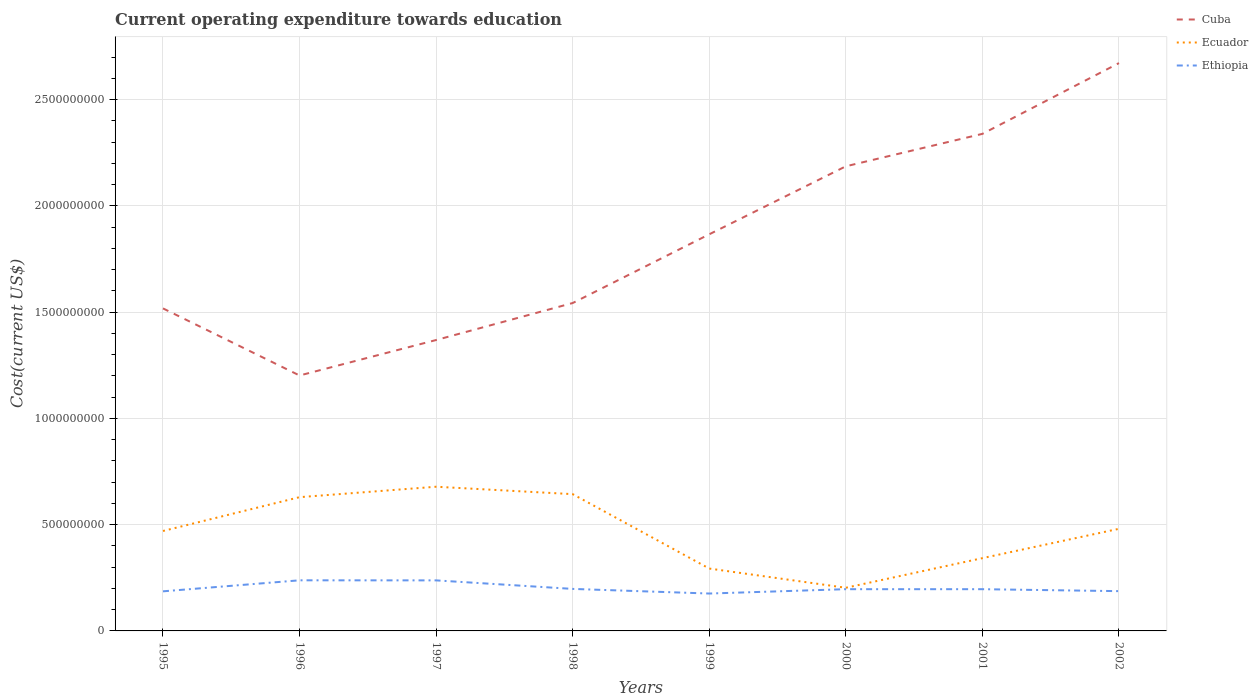Does the line corresponding to Ethiopia intersect with the line corresponding to Cuba?
Offer a terse response. No. Is the number of lines equal to the number of legend labels?
Ensure brevity in your answer.  Yes. Across all years, what is the maximum expenditure towards education in Cuba?
Make the answer very short. 1.20e+09. In which year was the expenditure towards education in Cuba maximum?
Your response must be concise. 1996. What is the total expenditure towards education in Ecuador in the graph?
Provide a succinct answer. 2.87e+08. What is the difference between the highest and the second highest expenditure towards education in Ethiopia?
Your answer should be compact. 6.22e+07. Is the expenditure towards education in Cuba strictly greater than the expenditure towards education in Ethiopia over the years?
Offer a terse response. No. How many years are there in the graph?
Give a very brief answer. 8. What is the difference between two consecutive major ticks on the Y-axis?
Provide a succinct answer. 5.00e+08. Does the graph contain grids?
Your response must be concise. Yes. Where does the legend appear in the graph?
Provide a short and direct response. Top right. How many legend labels are there?
Offer a terse response. 3. What is the title of the graph?
Offer a terse response. Current operating expenditure towards education. Does "Uganda" appear as one of the legend labels in the graph?
Provide a succinct answer. No. What is the label or title of the X-axis?
Ensure brevity in your answer.  Years. What is the label or title of the Y-axis?
Provide a short and direct response. Cost(current US$). What is the Cost(current US$) in Cuba in 1995?
Offer a terse response. 1.52e+09. What is the Cost(current US$) of Ecuador in 1995?
Offer a very short reply. 4.70e+08. What is the Cost(current US$) in Ethiopia in 1995?
Your response must be concise. 1.86e+08. What is the Cost(current US$) in Cuba in 1996?
Provide a short and direct response. 1.20e+09. What is the Cost(current US$) of Ecuador in 1996?
Give a very brief answer. 6.29e+08. What is the Cost(current US$) of Ethiopia in 1996?
Make the answer very short. 2.38e+08. What is the Cost(current US$) in Cuba in 1997?
Your answer should be compact. 1.37e+09. What is the Cost(current US$) of Ecuador in 1997?
Keep it short and to the point. 6.78e+08. What is the Cost(current US$) of Ethiopia in 1997?
Give a very brief answer. 2.38e+08. What is the Cost(current US$) of Cuba in 1998?
Provide a short and direct response. 1.54e+09. What is the Cost(current US$) of Ecuador in 1998?
Provide a short and direct response. 6.43e+08. What is the Cost(current US$) in Ethiopia in 1998?
Provide a succinct answer. 1.98e+08. What is the Cost(current US$) in Cuba in 1999?
Provide a succinct answer. 1.87e+09. What is the Cost(current US$) in Ecuador in 1999?
Your answer should be compact. 2.93e+08. What is the Cost(current US$) of Ethiopia in 1999?
Offer a terse response. 1.76e+08. What is the Cost(current US$) of Cuba in 2000?
Provide a succinct answer. 2.19e+09. What is the Cost(current US$) in Ecuador in 2000?
Your answer should be compact. 2.03e+08. What is the Cost(current US$) in Ethiopia in 2000?
Offer a very short reply. 1.96e+08. What is the Cost(current US$) of Cuba in 2001?
Provide a short and direct response. 2.34e+09. What is the Cost(current US$) of Ecuador in 2001?
Your response must be concise. 3.42e+08. What is the Cost(current US$) of Ethiopia in 2001?
Ensure brevity in your answer.  1.96e+08. What is the Cost(current US$) in Cuba in 2002?
Your answer should be very brief. 2.67e+09. What is the Cost(current US$) in Ecuador in 2002?
Provide a short and direct response. 4.80e+08. What is the Cost(current US$) of Ethiopia in 2002?
Keep it short and to the point. 1.87e+08. Across all years, what is the maximum Cost(current US$) in Cuba?
Offer a terse response. 2.67e+09. Across all years, what is the maximum Cost(current US$) in Ecuador?
Provide a succinct answer. 6.78e+08. Across all years, what is the maximum Cost(current US$) of Ethiopia?
Make the answer very short. 2.38e+08. Across all years, what is the minimum Cost(current US$) of Cuba?
Your answer should be very brief. 1.20e+09. Across all years, what is the minimum Cost(current US$) of Ecuador?
Provide a succinct answer. 2.03e+08. Across all years, what is the minimum Cost(current US$) in Ethiopia?
Your response must be concise. 1.76e+08. What is the total Cost(current US$) of Cuba in the graph?
Make the answer very short. 1.47e+1. What is the total Cost(current US$) in Ecuador in the graph?
Keep it short and to the point. 3.74e+09. What is the total Cost(current US$) in Ethiopia in the graph?
Give a very brief answer. 1.62e+09. What is the difference between the Cost(current US$) of Cuba in 1995 and that in 1996?
Provide a short and direct response. 3.16e+08. What is the difference between the Cost(current US$) of Ecuador in 1995 and that in 1996?
Provide a succinct answer. -1.59e+08. What is the difference between the Cost(current US$) in Ethiopia in 1995 and that in 1996?
Provide a short and direct response. -5.18e+07. What is the difference between the Cost(current US$) in Cuba in 1995 and that in 1997?
Give a very brief answer. 1.49e+08. What is the difference between the Cost(current US$) in Ecuador in 1995 and that in 1997?
Your answer should be very brief. -2.08e+08. What is the difference between the Cost(current US$) in Ethiopia in 1995 and that in 1997?
Offer a terse response. -5.15e+07. What is the difference between the Cost(current US$) in Cuba in 1995 and that in 1998?
Offer a very short reply. -2.52e+07. What is the difference between the Cost(current US$) in Ecuador in 1995 and that in 1998?
Make the answer very short. -1.73e+08. What is the difference between the Cost(current US$) of Ethiopia in 1995 and that in 1998?
Offer a very short reply. -1.14e+07. What is the difference between the Cost(current US$) in Cuba in 1995 and that in 1999?
Your response must be concise. -3.49e+08. What is the difference between the Cost(current US$) in Ecuador in 1995 and that in 1999?
Give a very brief answer. 1.77e+08. What is the difference between the Cost(current US$) of Ethiopia in 1995 and that in 1999?
Provide a succinct answer. 1.04e+07. What is the difference between the Cost(current US$) of Cuba in 1995 and that in 2000?
Your response must be concise. -6.69e+08. What is the difference between the Cost(current US$) in Ecuador in 1995 and that in 2000?
Make the answer very short. 2.67e+08. What is the difference between the Cost(current US$) of Ethiopia in 1995 and that in 2000?
Provide a succinct answer. -1.01e+07. What is the difference between the Cost(current US$) in Cuba in 1995 and that in 2001?
Ensure brevity in your answer.  -8.21e+08. What is the difference between the Cost(current US$) in Ecuador in 1995 and that in 2001?
Ensure brevity in your answer.  1.28e+08. What is the difference between the Cost(current US$) of Ethiopia in 1995 and that in 2001?
Keep it short and to the point. -1.00e+07. What is the difference between the Cost(current US$) of Cuba in 1995 and that in 2002?
Make the answer very short. -1.15e+09. What is the difference between the Cost(current US$) of Ecuador in 1995 and that in 2002?
Offer a terse response. -1.03e+07. What is the difference between the Cost(current US$) of Ethiopia in 1995 and that in 2002?
Ensure brevity in your answer.  -8.46e+05. What is the difference between the Cost(current US$) of Cuba in 1996 and that in 1997?
Provide a succinct answer. -1.67e+08. What is the difference between the Cost(current US$) in Ecuador in 1996 and that in 1997?
Make the answer very short. -4.91e+07. What is the difference between the Cost(current US$) of Ethiopia in 1996 and that in 1997?
Ensure brevity in your answer.  3.39e+05. What is the difference between the Cost(current US$) of Cuba in 1996 and that in 1998?
Give a very brief answer. -3.41e+08. What is the difference between the Cost(current US$) in Ecuador in 1996 and that in 1998?
Make the answer very short. -1.42e+07. What is the difference between the Cost(current US$) of Ethiopia in 1996 and that in 1998?
Ensure brevity in your answer.  4.05e+07. What is the difference between the Cost(current US$) in Cuba in 1996 and that in 1999?
Keep it short and to the point. -6.64e+08. What is the difference between the Cost(current US$) in Ecuador in 1996 and that in 1999?
Offer a very short reply. 3.36e+08. What is the difference between the Cost(current US$) of Ethiopia in 1996 and that in 1999?
Your answer should be very brief. 6.22e+07. What is the difference between the Cost(current US$) of Cuba in 1996 and that in 2000?
Offer a very short reply. -9.84e+08. What is the difference between the Cost(current US$) in Ecuador in 1996 and that in 2000?
Your answer should be very brief. 4.26e+08. What is the difference between the Cost(current US$) of Ethiopia in 1996 and that in 2000?
Your answer should be very brief. 4.17e+07. What is the difference between the Cost(current US$) of Cuba in 1996 and that in 2001?
Offer a very short reply. -1.14e+09. What is the difference between the Cost(current US$) in Ecuador in 1996 and that in 2001?
Give a very brief answer. 2.87e+08. What is the difference between the Cost(current US$) in Ethiopia in 1996 and that in 2001?
Offer a very short reply. 4.18e+07. What is the difference between the Cost(current US$) in Cuba in 1996 and that in 2002?
Give a very brief answer. -1.47e+09. What is the difference between the Cost(current US$) of Ecuador in 1996 and that in 2002?
Provide a succinct answer. 1.49e+08. What is the difference between the Cost(current US$) in Ethiopia in 1996 and that in 2002?
Make the answer very short. 5.10e+07. What is the difference between the Cost(current US$) of Cuba in 1997 and that in 1998?
Your answer should be compact. -1.74e+08. What is the difference between the Cost(current US$) of Ecuador in 1997 and that in 1998?
Provide a short and direct response. 3.49e+07. What is the difference between the Cost(current US$) in Ethiopia in 1997 and that in 1998?
Make the answer very short. 4.01e+07. What is the difference between the Cost(current US$) in Cuba in 1997 and that in 1999?
Your response must be concise. -4.97e+08. What is the difference between the Cost(current US$) of Ecuador in 1997 and that in 1999?
Offer a terse response. 3.85e+08. What is the difference between the Cost(current US$) in Ethiopia in 1997 and that in 1999?
Your answer should be very brief. 6.19e+07. What is the difference between the Cost(current US$) in Cuba in 1997 and that in 2000?
Ensure brevity in your answer.  -8.17e+08. What is the difference between the Cost(current US$) in Ecuador in 1997 and that in 2000?
Give a very brief answer. 4.75e+08. What is the difference between the Cost(current US$) of Ethiopia in 1997 and that in 2000?
Keep it short and to the point. 4.14e+07. What is the difference between the Cost(current US$) of Cuba in 1997 and that in 2001?
Your response must be concise. -9.70e+08. What is the difference between the Cost(current US$) in Ecuador in 1997 and that in 2001?
Provide a short and direct response. 3.36e+08. What is the difference between the Cost(current US$) of Ethiopia in 1997 and that in 2001?
Your answer should be very brief. 4.15e+07. What is the difference between the Cost(current US$) in Cuba in 1997 and that in 2002?
Offer a terse response. -1.30e+09. What is the difference between the Cost(current US$) of Ecuador in 1997 and that in 2002?
Make the answer very short. 1.98e+08. What is the difference between the Cost(current US$) in Ethiopia in 1997 and that in 2002?
Provide a short and direct response. 5.07e+07. What is the difference between the Cost(current US$) of Cuba in 1998 and that in 1999?
Ensure brevity in your answer.  -3.23e+08. What is the difference between the Cost(current US$) in Ecuador in 1998 and that in 1999?
Ensure brevity in your answer.  3.50e+08. What is the difference between the Cost(current US$) of Ethiopia in 1998 and that in 1999?
Give a very brief answer. 2.18e+07. What is the difference between the Cost(current US$) in Cuba in 1998 and that in 2000?
Give a very brief answer. -6.43e+08. What is the difference between the Cost(current US$) in Ecuador in 1998 and that in 2000?
Offer a terse response. 4.40e+08. What is the difference between the Cost(current US$) in Ethiopia in 1998 and that in 2000?
Make the answer very short. 1.30e+06. What is the difference between the Cost(current US$) of Cuba in 1998 and that in 2001?
Your answer should be very brief. -7.96e+08. What is the difference between the Cost(current US$) in Ecuador in 1998 and that in 2001?
Keep it short and to the point. 3.01e+08. What is the difference between the Cost(current US$) in Ethiopia in 1998 and that in 2001?
Offer a terse response. 1.35e+06. What is the difference between the Cost(current US$) in Cuba in 1998 and that in 2002?
Give a very brief answer. -1.13e+09. What is the difference between the Cost(current US$) of Ecuador in 1998 and that in 2002?
Provide a succinct answer. 1.63e+08. What is the difference between the Cost(current US$) of Ethiopia in 1998 and that in 2002?
Offer a terse response. 1.05e+07. What is the difference between the Cost(current US$) of Cuba in 1999 and that in 2000?
Your response must be concise. -3.20e+08. What is the difference between the Cost(current US$) in Ecuador in 1999 and that in 2000?
Your answer should be compact. 9.04e+07. What is the difference between the Cost(current US$) in Ethiopia in 1999 and that in 2000?
Offer a very short reply. -2.05e+07. What is the difference between the Cost(current US$) in Cuba in 1999 and that in 2001?
Your answer should be compact. -4.73e+08. What is the difference between the Cost(current US$) in Ecuador in 1999 and that in 2001?
Your response must be concise. -4.90e+07. What is the difference between the Cost(current US$) of Ethiopia in 1999 and that in 2001?
Offer a terse response. -2.04e+07. What is the difference between the Cost(current US$) in Cuba in 1999 and that in 2002?
Ensure brevity in your answer.  -8.05e+08. What is the difference between the Cost(current US$) in Ecuador in 1999 and that in 2002?
Your answer should be compact. -1.87e+08. What is the difference between the Cost(current US$) in Ethiopia in 1999 and that in 2002?
Provide a succinct answer. -1.12e+07. What is the difference between the Cost(current US$) in Cuba in 2000 and that in 2001?
Offer a very short reply. -1.53e+08. What is the difference between the Cost(current US$) of Ecuador in 2000 and that in 2001?
Give a very brief answer. -1.39e+08. What is the difference between the Cost(current US$) of Ethiopia in 2000 and that in 2001?
Offer a very short reply. 5.27e+04. What is the difference between the Cost(current US$) of Cuba in 2000 and that in 2002?
Make the answer very short. -4.86e+08. What is the difference between the Cost(current US$) of Ecuador in 2000 and that in 2002?
Your answer should be compact. -2.77e+08. What is the difference between the Cost(current US$) in Ethiopia in 2000 and that in 2002?
Offer a terse response. 9.24e+06. What is the difference between the Cost(current US$) in Cuba in 2001 and that in 2002?
Your answer should be very brief. -3.33e+08. What is the difference between the Cost(current US$) in Ecuador in 2001 and that in 2002?
Ensure brevity in your answer.  -1.38e+08. What is the difference between the Cost(current US$) of Ethiopia in 2001 and that in 2002?
Ensure brevity in your answer.  9.19e+06. What is the difference between the Cost(current US$) of Cuba in 1995 and the Cost(current US$) of Ecuador in 1996?
Your answer should be very brief. 8.88e+08. What is the difference between the Cost(current US$) of Cuba in 1995 and the Cost(current US$) of Ethiopia in 1996?
Keep it short and to the point. 1.28e+09. What is the difference between the Cost(current US$) in Ecuador in 1995 and the Cost(current US$) in Ethiopia in 1996?
Provide a short and direct response. 2.32e+08. What is the difference between the Cost(current US$) of Cuba in 1995 and the Cost(current US$) of Ecuador in 1997?
Your answer should be compact. 8.39e+08. What is the difference between the Cost(current US$) of Cuba in 1995 and the Cost(current US$) of Ethiopia in 1997?
Ensure brevity in your answer.  1.28e+09. What is the difference between the Cost(current US$) of Ecuador in 1995 and the Cost(current US$) of Ethiopia in 1997?
Provide a succinct answer. 2.32e+08. What is the difference between the Cost(current US$) in Cuba in 1995 and the Cost(current US$) in Ecuador in 1998?
Ensure brevity in your answer.  8.74e+08. What is the difference between the Cost(current US$) in Cuba in 1995 and the Cost(current US$) in Ethiopia in 1998?
Provide a short and direct response. 1.32e+09. What is the difference between the Cost(current US$) of Ecuador in 1995 and the Cost(current US$) of Ethiopia in 1998?
Provide a succinct answer. 2.72e+08. What is the difference between the Cost(current US$) in Cuba in 1995 and the Cost(current US$) in Ecuador in 1999?
Keep it short and to the point. 1.22e+09. What is the difference between the Cost(current US$) in Cuba in 1995 and the Cost(current US$) in Ethiopia in 1999?
Keep it short and to the point. 1.34e+09. What is the difference between the Cost(current US$) in Ecuador in 1995 and the Cost(current US$) in Ethiopia in 1999?
Ensure brevity in your answer.  2.94e+08. What is the difference between the Cost(current US$) of Cuba in 1995 and the Cost(current US$) of Ecuador in 2000?
Give a very brief answer. 1.31e+09. What is the difference between the Cost(current US$) in Cuba in 1995 and the Cost(current US$) in Ethiopia in 2000?
Offer a terse response. 1.32e+09. What is the difference between the Cost(current US$) in Ecuador in 1995 and the Cost(current US$) in Ethiopia in 2000?
Give a very brief answer. 2.74e+08. What is the difference between the Cost(current US$) in Cuba in 1995 and the Cost(current US$) in Ecuador in 2001?
Provide a succinct answer. 1.17e+09. What is the difference between the Cost(current US$) in Cuba in 1995 and the Cost(current US$) in Ethiopia in 2001?
Make the answer very short. 1.32e+09. What is the difference between the Cost(current US$) in Ecuador in 1995 and the Cost(current US$) in Ethiopia in 2001?
Your response must be concise. 2.74e+08. What is the difference between the Cost(current US$) in Cuba in 1995 and the Cost(current US$) in Ecuador in 2002?
Provide a short and direct response. 1.04e+09. What is the difference between the Cost(current US$) in Cuba in 1995 and the Cost(current US$) in Ethiopia in 2002?
Your answer should be compact. 1.33e+09. What is the difference between the Cost(current US$) in Ecuador in 1995 and the Cost(current US$) in Ethiopia in 2002?
Provide a short and direct response. 2.83e+08. What is the difference between the Cost(current US$) in Cuba in 1996 and the Cost(current US$) in Ecuador in 1997?
Provide a succinct answer. 5.23e+08. What is the difference between the Cost(current US$) in Cuba in 1996 and the Cost(current US$) in Ethiopia in 1997?
Your answer should be compact. 9.64e+08. What is the difference between the Cost(current US$) of Ecuador in 1996 and the Cost(current US$) of Ethiopia in 1997?
Provide a succinct answer. 3.91e+08. What is the difference between the Cost(current US$) of Cuba in 1996 and the Cost(current US$) of Ecuador in 1998?
Provide a succinct answer. 5.58e+08. What is the difference between the Cost(current US$) of Cuba in 1996 and the Cost(current US$) of Ethiopia in 1998?
Your answer should be compact. 1.00e+09. What is the difference between the Cost(current US$) in Ecuador in 1996 and the Cost(current US$) in Ethiopia in 1998?
Your answer should be very brief. 4.32e+08. What is the difference between the Cost(current US$) of Cuba in 1996 and the Cost(current US$) of Ecuador in 1999?
Offer a terse response. 9.08e+08. What is the difference between the Cost(current US$) in Cuba in 1996 and the Cost(current US$) in Ethiopia in 1999?
Ensure brevity in your answer.  1.03e+09. What is the difference between the Cost(current US$) in Ecuador in 1996 and the Cost(current US$) in Ethiopia in 1999?
Your response must be concise. 4.53e+08. What is the difference between the Cost(current US$) in Cuba in 1996 and the Cost(current US$) in Ecuador in 2000?
Provide a short and direct response. 9.99e+08. What is the difference between the Cost(current US$) in Cuba in 1996 and the Cost(current US$) in Ethiopia in 2000?
Make the answer very short. 1.01e+09. What is the difference between the Cost(current US$) in Ecuador in 1996 and the Cost(current US$) in Ethiopia in 2000?
Provide a short and direct response. 4.33e+08. What is the difference between the Cost(current US$) of Cuba in 1996 and the Cost(current US$) of Ecuador in 2001?
Your response must be concise. 8.59e+08. What is the difference between the Cost(current US$) in Cuba in 1996 and the Cost(current US$) in Ethiopia in 2001?
Your response must be concise. 1.01e+09. What is the difference between the Cost(current US$) of Ecuador in 1996 and the Cost(current US$) of Ethiopia in 2001?
Give a very brief answer. 4.33e+08. What is the difference between the Cost(current US$) in Cuba in 1996 and the Cost(current US$) in Ecuador in 2002?
Keep it short and to the point. 7.21e+08. What is the difference between the Cost(current US$) in Cuba in 1996 and the Cost(current US$) in Ethiopia in 2002?
Provide a succinct answer. 1.01e+09. What is the difference between the Cost(current US$) in Ecuador in 1996 and the Cost(current US$) in Ethiopia in 2002?
Your response must be concise. 4.42e+08. What is the difference between the Cost(current US$) of Cuba in 1997 and the Cost(current US$) of Ecuador in 1998?
Give a very brief answer. 7.25e+08. What is the difference between the Cost(current US$) in Cuba in 1997 and the Cost(current US$) in Ethiopia in 1998?
Provide a short and direct response. 1.17e+09. What is the difference between the Cost(current US$) in Ecuador in 1997 and the Cost(current US$) in Ethiopia in 1998?
Your response must be concise. 4.81e+08. What is the difference between the Cost(current US$) in Cuba in 1997 and the Cost(current US$) in Ecuador in 1999?
Your answer should be compact. 1.08e+09. What is the difference between the Cost(current US$) of Cuba in 1997 and the Cost(current US$) of Ethiopia in 1999?
Give a very brief answer. 1.19e+09. What is the difference between the Cost(current US$) in Ecuador in 1997 and the Cost(current US$) in Ethiopia in 1999?
Provide a short and direct response. 5.02e+08. What is the difference between the Cost(current US$) in Cuba in 1997 and the Cost(current US$) in Ecuador in 2000?
Offer a very short reply. 1.17e+09. What is the difference between the Cost(current US$) in Cuba in 1997 and the Cost(current US$) in Ethiopia in 2000?
Make the answer very short. 1.17e+09. What is the difference between the Cost(current US$) of Ecuador in 1997 and the Cost(current US$) of Ethiopia in 2000?
Provide a short and direct response. 4.82e+08. What is the difference between the Cost(current US$) in Cuba in 1997 and the Cost(current US$) in Ecuador in 2001?
Your response must be concise. 1.03e+09. What is the difference between the Cost(current US$) of Cuba in 1997 and the Cost(current US$) of Ethiopia in 2001?
Provide a short and direct response. 1.17e+09. What is the difference between the Cost(current US$) of Ecuador in 1997 and the Cost(current US$) of Ethiopia in 2001?
Ensure brevity in your answer.  4.82e+08. What is the difference between the Cost(current US$) of Cuba in 1997 and the Cost(current US$) of Ecuador in 2002?
Offer a very short reply. 8.88e+08. What is the difference between the Cost(current US$) of Cuba in 1997 and the Cost(current US$) of Ethiopia in 2002?
Your response must be concise. 1.18e+09. What is the difference between the Cost(current US$) of Ecuador in 1997 and the Cost(current US$) of Ethiopia in 2002?
Offer a very short reply. 4.91e+08. What is the difference between the Cost(current US$) of Cuba in 1998 and the Cost(current US$) of Ecuador in 1999?
Keep it short and to the point. 1.25e+09. What is the difference between the Cost(current US$) of Cuba in 1998 and the Cost(current US$) of Ethiopia in 1999?
Your answer should be compact. 1.37e+09. What is the difference between the Cost(current US$) of Ecuador in 1998 and the Cost(current US$) of Ethiopia in 1999?
Provide a succinct answer. 4.68e+08. What is the difference between the Cost(current US$) in Cuba in 1998 and the Cost(current US$) in Ecuador in 2000?
Provide a short and direct response. 1.34e+09. What is the difference between the Cost(current US$) in Cuba in 1998 and the Cost(current US$) in Ethiopia in 2000?
Your answer should be compact. 1.35e+09. What is the difference between the Cost(current US$) of Ecuador in 1998 and the Cost(current US$) of Ethiopia in 2000?
Make the answer very short. 4.47e+08. What is the difference between the Cost(current US$) of Cuba in 1998 and the Cost(current US$) of Ecuador in 2001?
Your answer should be very brief. 1.20e+09. What is the difference between the Cost(current US$) in Cuba in 1998 and the Cost(current US$) in Ethiopia in 2001?
Your response must be concise. 1.35e+09. What is the difference between the Cost(current US$) in Ecuador in 1998 and the Cost(current US$) in Ethiopia in 2001?
Your response must be concise. 4.47e+08. What is the difference between the Cost(current US$) of Cuba in 1998 and the Cost(current US$) of Ecuador in 2002?
Keep it short and to the point. 1.06e+09. What is the difference between the Cost(current US$) of Cuba in 1998 and the Cost(current US$) of Ethiopia in 2002?
Your answer should be very brief. 1.36e+09. What is the difference between the Cost(current US$) of Ecuador in 1998 and the Cost(current US$) of Ethiopia in 2002?
Keep it short and to the point. 4.56e+08. What is the difference between the Cost(current US$) of Cuba in 1999 and the Cost(current US$) of Ecuador in 2000?
Offer a terse response. 1.66e+09. What is the difference between the Cost(current US$) in Cuba in 1999 and the Cost(current US$) in Ethiopia in 2000?
Ensure brevity in your answer.  1.67e+09. What is the difference between the Cost(current US$) in Ecuador in 1999 and the Cost(current US$) in Ethiopia in 2000?
Make the answer very short. 9.70e+07. What is the difference between the Cost(current US$) of Cuba in 1999 and the Cost(current US$) of Ecuador in 2001?
Your answer should be very brief. 1.52e+09. What is the difference between the Cost(current US$) in Cuba in 1999 and the Cost(current US$) in Ethiopia in 2001?
Offer a very short reply. 1.67e+09. What is the difference between the Cost(current US$) in Ecuador in 1999 and the Cost(current US$) in Ethiopia in 2001?
Provide a succinct answer. 9.71e+07. What is the difference between the Cost(current US$) of Cuba in 1999 and the Cost(current US$) of Ecuador in 2002?
Keep it short and to the point. 1.39e+09. What is the difference between the Cost(current US$) in Cuba in 1999 and the Cost(current US$) in Ethiopia in 2002?
Provide a succinct answer. 1.68e+09. What is the difference between the Cost(current US$) in Ecuador in 1999 and the Cost(current US$) in Ethiopia in 2002?
Offer a very short reply. 1.06e+08. What is the difference between the Cost(current US$) of Cuba in 2000 and the Cost(current US$) of Ecuador in 2001?
Offer a terse response. 1.84e+09. What is the difference between the Cost(current US$) in Cuba in 2000 and the Cost(current US$) in Ethiopia in 2001?
Provide a succinct answer. 1.99e+09. What is the difference between the Cost(current US$) of Ecuador in 2000 and the Cost(current US$) of Ethiopia in 2001?
Your answer should be very brief. 6.67e+06. What is the difference between the Cost(current US$) of Cuba in 2000 and the Cost(current US$) of Ecuador in 2002?
Make the answer very short. 1.71e+09. What is the difference between the Cost(current US$) of Cuba in 2000 and the Cost(current US$) of Ethiopia in 2002?
Offer a very short reply. 2.00e+09. What is the difference between the Cost(current US$) in Ecuador in 2000 and the Cost(current US$) in Ethiopia in 2002?
Keep it short and to the point. 1.59e+07. What is the difference between the Cost(current US$) in Cuba in 2001 and the Cost(current US$) in Ecuador in 2002?
Your answer should be compact. 1.86e+09. What is the difference between the Cost(current US$) of Cuba in 2001 and the Cost(current US$) of Ethiopia in 2002?
Your answer should be very brief. 2.15e+09. What is the difference between the Cost(current US$) of Ecuador in 2001 and the Cost(current US$) of Ethiopia in 2002?
Ensure brevity in your answer.  1.55e+08. What is the average Cost(current US$) of Cuba per year?
Your answer should be very brief. 1.84e+09. What is the average Cost(current US$) in Ecuador per year?
Provide a succinct answer. 4.68e+08. What is the average Cost(current US$) in Ethiopia per year?
Keep it short and to the point. 2.02e+08. In the year 1995, what is the difference between the Cost(current US$) in Cuba and Cost(current US$) in Ecuador?
Give a very brief answer. 1.05e+09. In the year 1995, what is the difference between the Cost(current US$) of Cuba and Cost(current US$) of Ethiopia?
Keep it short and to the point. 1.33e+09. In the year 1995, what is the difference between the Cost(current US$) in Ecuador and Cost(current US$) in Ethiopia?
Your answer should be very brief. 2.84e+08. In the year 1996, what is the difference between the Cost(current US$) of Cuba and Cost(current US$) of Ecuador?
Make the answer very short. 5.72e+08. In the year 1996, what is the difference between the Cost(current US$) in Cuba and Cost(current US$) in Ethiopia?
Make the answer very short. 9.64e+08. In the year 1996, what is the difference between the Cost(current US$) in Ecuador and Cost(current US$) in Ethiopia?
Offer a terse response. 3.91e+08. In the year 1997, what is the difference between the Cost(current US$) in Cuba and Cost(current US$) in Ecuador?
Your answer should be compact. 6.90e+08. In the year 1997, what is the difference between the Cost(current US$) of Cuba and Cost(current US$) of Ethiopia?
Provide a short and direct response. 1.13e+09. In the year 1997, what is the difference between the Cost(current US$) of Ecuador and Cost(current US$) of Ethiopia?
Your answer should be compact. 4.41e+08. In the year 1998, what is the difference between the Cost(current US$) of Cuba and Cost(current US$) of Ecuador?
Your response must be concise. 8.99e+08. In the year 1998, what is the difference between the Cost(current US$) of Cuba and Cost(current US$) of Ethiopia?
Your response must be concise. 1.34e+09. In the year 1998, what is the difference between the Cost(current US$) of Ecuador and Cost(current US$) of Ethiopia?
Ensure brevity in your answer.  4.46e+08. In the year 1999, what is the difference between the Cost(current US$) in Cuba and Cost(current US$) in Ecuador?
Give a very brief answer. 1.57e+09. In the year 1999, what is the difference between the Cost(current US$) in Cuba and Cost(current US$) in Ethiopia?
Provide a short and direct response. 1.69e+09. In the year 1999, what is the difference between the Cost(current US$) of Ecuador and Cost(current US$) of Ethiopia?
Offer a very short reply. 1.17e+08. In the year 2000, what is the difference between the Cost(current US$) in Cuba and Cost(current US$) in Ecuador?
Keep it short and to the point. 1.98e+09. In the year 2000, what is the difference between the Cost(current US$) of Cuba and Cost(current US$) of Ethiopia?
Ensure brevity in your answer.  1.99e+09. In the year 2000, what is the difference between the Cost(current US$) in Ecuador and Cost(current US$) in Ethiopia?
Your response must be concise. 6.62e+06. In the year 2001, what is the difference between the Cost(current US$) in Cuba and Cost(current US$) in Ecuador?
Ensure brevity in your answer.  2.00e+09. In the year 2001, what is the difference between the Cost(current US$) in Cuba and Cost(current US$) in Ethiopia?
Keep it short and to the point. 2.14e+09. In the year 2001, what is the difference between the Cost(current US$) in Ecuador and Cost(current US$) in Ethiopia?
Give a very brief answer. 1.46e+08. In the year 2002, what is the difference between the Cost(current US$) in Cuba and Cost(current US$) in Ecuador?
Give a very brief answer. 2.19e+09. In the year 2002, what is the difference between the Cost(current US$) in Cuba and Cost(current US$) in Ethiopia?
Make the answer very short. 2.48e+09. In the year 2002, what is the difference between the Cost(current US$) of Ecuador and Cost(current US$) of Ethiopia?
Provide a succinct answer. 2.93e+08. What is the ratio of the Cost(current US$) of Cuba in 1995 to that in 1996?
Your answer should be very brief. 1.26. What is the ratio of the Cost(current US$) in Ecuador in 1995 to that in 1996?
Provide a short and direct response. 0.75. What is the ratio of the Cost(current US$) of Ethiopia in 1995 to that in 1996?
Your answer should be compact. 0.78. What is the ratio of the Cost(current US$) in Cuba in 1995 to that in 1997?
Your response must be concise. 1.11. What is the ratio of the Cost(current US$) in Ecuador in 1995 to that in 1997?
Ensure brevity in your answer.  0.69. What is the ratio of the Cost(current US$) of Ethiopia in 1995 to that in 1997?
Ensure brevity in your answer.  0.78. What is the ratio of the Cost(current US$) in Cuba in 1995 to that in 1998?
Your response must be concise. 0.98. What is the ratio of the Cost(current US$) of Ecuador in 1995 to that in 1998?
Provide a succinct answer. 0.73. What is the ratio of the Cost(current US$) in Ethiopia in 1995 to that in 1998?
Offer a terse response. 0.94. What is the ratio of the Cost(current US$) in Cuba in 1995 to that in 1999?
Provide a succinct answer. 0.81. What is the ratio of the Cost(current US$) in Ecuador in 1995 to that in 1999?
Provide a short and direct response. 1.6. What is the ratio of the Cost(current US$) of Ethiopia in 1995 to that in 1999?
Your answer should be very brief. 1.06. What is the ratio of the Cost(current US$) in Cuba in 1995 to that in 2000?
Keep it short and to the point. 0.69. What is the ratio of the Cost(current US$) of Ecuador in 1995 to that in 2000?
Offer a terse response. 2.32. What is the ratio of the Cost(current US$) in Ethiopia in 1995 to that in 2000?
Ensure brevity in your answer.  0.95. What is the ratio of the Cost(current US$) of Cuba in 1995 to that in 2001?
Offer a terse response. 0.65. What is the ratio of the Cost(current US$) in Ecuador in 1995 to that in 2001?
Keep it short and to the point. 1.37. What is the ratio of the Cost(current US$) in Ethiopia in 1995 to that in 2001?
Provide a short and direct response. 0.95. What is the ratio of the Cost(current US$) of Cuba in 1995 to that in 2002?
Keep it short and to the point. 0.57. What is the ratio of the Cost(current US$) in Ecuador in 1995 to that in 2002?
Your response must be concise. 0.98. What is the ratio of the Cost(current US$) of Ethiopia in 1995 to that in 2002?
Keep it short and to the point. 1. What is the ratio of the Cost(current US$) in Cuba in 1996 to that in 1997?
Provide a succinct answer. 0.88. What is the ratio of the Cost(current US$) in Ecuador in 1996 to that in 1997?
Give a very brief answer. 0.93. What is the ratio of the Cost(current US$) of Ethiopia in 1996 to that in 1997?
Offer a terse response. 1. What is the ratio of the Cost(current US$) of Cuba in 1996 to that in 1998?
Offer a terse response. 0.78. What is the ratio of the Cost(current US$) of Ethiopia in 1996 to that in 1998?
Your answer should be very brief. 1.2. What is the ratio of the Cost(current US$) in Cuba in 1996 to that in 1999?
Provide a succinct answer. 0.64. What is the ratio of the Cost(current US$) in Ecuador in 1996 to that in 1999?
Give a very brief answer. 2.14. What is the ratio of the Cost(current US$) of Ethiopia in 1996 to that in 1999?
Ensure brevity in your answer.  1.35. What is the ratio of the Cost(current US$) of Cuba in 1996 to that in 2000?
Your answer should be compact. 0.55. What is the ratio of the Cost(current US$) in Ecuador in 1996 to that in 2000?
Your answer should be compact. 3.1. What is the ratio of the Cost(current US$) of Ethiopia in 1996 to that in 2000?
Ensure brevity in your answer.  1.21. What is the ratio of the Cost(current US$) in Cuba in 1996 to that in 2001?
Keep it short and to the point. 0.51. What is the ratio of the Cost(current US$) in Ecuador in 1996 to that in 2001?
Provide a succinct answer. 1.84. What is the ratio of the Cost(current US$) in Ethiopia in 1996 to that in 2001?
Your answer should be compact. 1.21. What is the ratio of the Cost(current US$) in Cuba in 1996 to that in 2002?
Keep it short and to the point. 0.45. What is the ratio of the Cost(current US$) in Ecuador in 1996 to that in 2002?
Provide a succinct answer. 1.31. What is the ratio of the Cost(current US$) of Ethiopia in 1996 to that in 2002?
Your answer should be very brief. 1.27. What is the ratio of the Cost(current US$) in Cuba in 1997 to that in 1998?
Offer a very short reply. 0.89. What is the ratio of the Cost(current US$) of Ecuador in 1997 to that in 1998?
Keep it short and to the point. 1.05. What is the ratio of the Cost(current US$) of Ethiopia in 1997 to that in 1998?
Make the answer very short. 1.2. What is the ratio of the Cost(current US$) of Cuba in 1997 to that in 1999?
Keep it short and to the point. 0.73. What is the ratio of the Cost(current US$) in Ecuador in 1997 to that in 1999?
Your response must be concise. 2.31. What is the ratio of the Cost(current US$) in Ethiopia in 1997 to that in 1999?
Ensure brevity in your answer.  1.35. What is the ratio of the Cost(current US$) of Cuba in 1997 to that in 2000?
Keep it short and to the point. 0.63. What is the ratio of the Cost(current US$) of Ecuador in 1997 to that in 2000?
Keep it short and to the point. 3.34. What is the ratio of the Cost(current US$) in Ethiopia in 1997 to that in 2000?
Your answer should be very brief. 1.21. What is the ratio of the Cost(current US$) in Cuba in 1997 to that in 2001?
Offer a very short reply. 0.59. What is the ratio of the Cost(current US$) of Ecuador in 1997 to that in 2001?
Ensure brevity in your answer.  1.98. What is the ratio of the Cost(current US$) in Ethiopia in 1997 to that in 2001?
Your answer should be very brief. 1.21. What is the ratio of the Cost(current US$) of Cuba in 1997 to that in 2002?
Make the answer very short. 0.51. What is the ratio of the Cost(current US$) of Ecuador in 1997 to that in 2002?
Provide a succinct answer. 1.41. What is the ratio of the Cost(current US$) of Ethiopia in 1997 to that in 2002?
Your answer should be compact. 1.27. What is the ratio of the Cost(current US$) of Cuba in 1998 to that in 1999?
Offer a terse response. 0.83. What is the ratio of the Cost(current US$) in Ecuador in 1998 to that in 1999?
Keep it short and to the point. 2.19. What is the ratio of the Cost(current US$) in Ethiopia in 1998 to that in 1999?
Make the answer very short. 1.12. What is the ratio of the Cost(current US$) in Cuba in 1998 to that in 2000?
Your answer should be very brief. 0.71. What is the ratio of the Cost(current US$) of Ecuador in 1998 to that in 2000?
Offer a very short reply. 3.17. What is the ratio of the Cost(current US$) in Ethiopia in 1998 to that in 2000?
Offer a very short reply. 1.01. What is the ratio of the Cost(current US$) of Cuba in 1998 to that in 2001?
Offer a very short reply. 0.66. What is the ratio of the Cost(current US$) of Ecuador in 1998 to that in 2001?
Make the answer very short. 1.88. What is the ratio of the Cost(current US$) of Cuba in 1998 to that in 2002?
Ensure brevity in your answer.  0.58. What is the ratio of the Cost(current US$) in Ecuador in 1998 to that in 2002?
Ensure brevity in your answer.  1.34. What is the ratio of the Cost(current US$) of Ethiopia in 1998 to that in 2002?
Your answer should be compact. 1.06. What is the ratio of the Cost(current US$) of Cuba in 1999 to that in 2000?
Offer a terse response. 0.85. What is the ratio of the Cost(current US$) in Ecuador in 1999 to that in 2000?
Your answer should be very brief. 1.45. What is the ratio of the Cost(current US$) of Ethiopia in 1999 to that in 2000?
Provide a succinct answer. 0.9. What is the ratio of the Cost(current US$) in Cuba in 1999 to that in 2001?
Give a very brief answer. 0.8. What is the ratio of the Cost(current US$) of Ecuador in 1999 to that in 2001?
Make the answer very short. 0.86. What is the ratio of the Cost(current US$) in Ethiopia in 1999 to that in 2001?
Ensure brevity in your answer.  0.9. What is the ratio of the Cost(current US$) in Cuba in 1999 to that in 2002?
Offer a very short reply. 0.7. What is the ratio of the Cost(current US$) in Ecuador in 1999 to that in 2002?
Give a very brief answer. 0.61. What is the ratio of the Cost(current US$) of Cuba in 2000 to that in 2001?
Keep it short and to the point. 0.93. What is the ratio of the Cost(current US$) in Ecuador in 2000 to that in 2001?
Offer a terse response. 0.59. What is the ratio of the Cost(current US$) of Ethiopia in 2000 to that in 2001?
Provide a succinct answer. 1. What is the ratio of the Cost(current US$) of Cuba in 2000 to that in 2002?
Ensure brevity in your answer.  0.82. What is the ratio of the Cost(current US$) in Ecuador in 2000 to that in 2002?
Your answer should be compact. 0.42. What is the ratio of the Cost(current US$) in Ethiopia in 2000 to that in 2002?
Ensure brevity in your answer.  1.05. What is the ratio of the Cost(current US$) in Cuba in 2001 to that in 2002?
Make the answer very short. 0.88. What is the ratio of the Cost(current US$) in Ecuador in 2001 to that in 2002?
Your answer should be very brief. 0.71. What is the ratio of the Cost(current US$) of Ethiopia in 2001 to that in 2002?
Make the answer very short. 1.05. What is the difference between the highest and the second highest Cost(current US$) of Cuba?
Provide a succinct answer. 3.33e+08. What is the difference between the highest and the second highest Cost(current US$) of Ecuador?
Offer a very short reply. 3.49e+07. What is the difference between the highest and the second highest Cost(current US$) of Ethiopia?
Provide a succinct answer. 3.39e+05. What is the difference between the highest and the lowest Cost(current US$) of Cuba?
Provide a short and direct response. 1.47e+09. What is the difference between the highest and the lowest Cost(current US$) of Ecuador?
Give a very brief answer. 4.75e+08. What is the difference between the highest and the lowest Cost(current US$) in Ethiopia?
Give a very brief answer. 6.22e+07. 